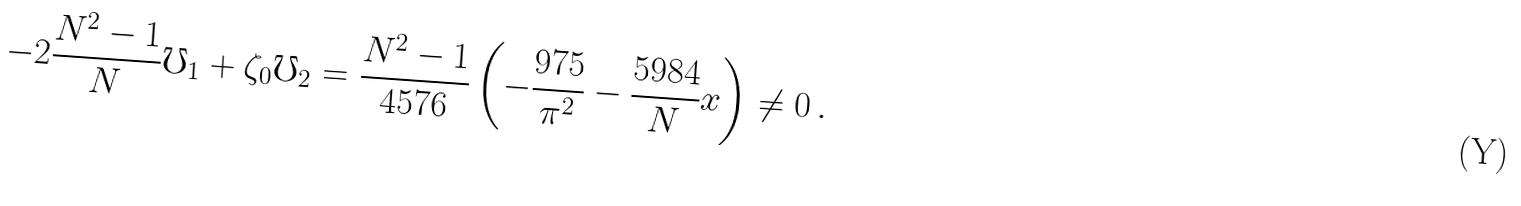<formula> <loc_0><loc_0><loc_500><loc_500>- 2 \frac { N ^ { 2 } - 1 } { N } \mho _ { 1 } + \zeta _ { 0 } \mho _ { 2 } = \frac { N ^ { 2 } - 1 } { 4 5 7 6 } \left ( - \frac { 9 7 5 } { \pi ^ { 2 } } - \frac { 5 9 8 4 } { N } x \right ) \neq 0 \, .</formula> 